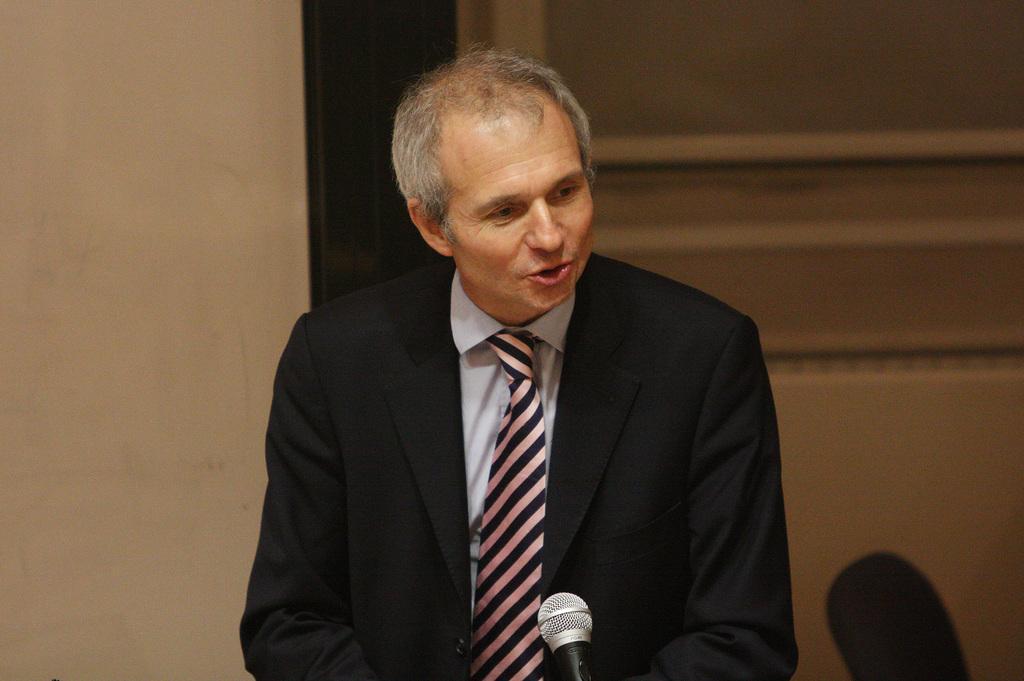Could you give a brief overview of what you see in this image? In the center of the image, we can see a person wearing a coat and a tie and there is a mic. In the background, there is a chair and a wall. 